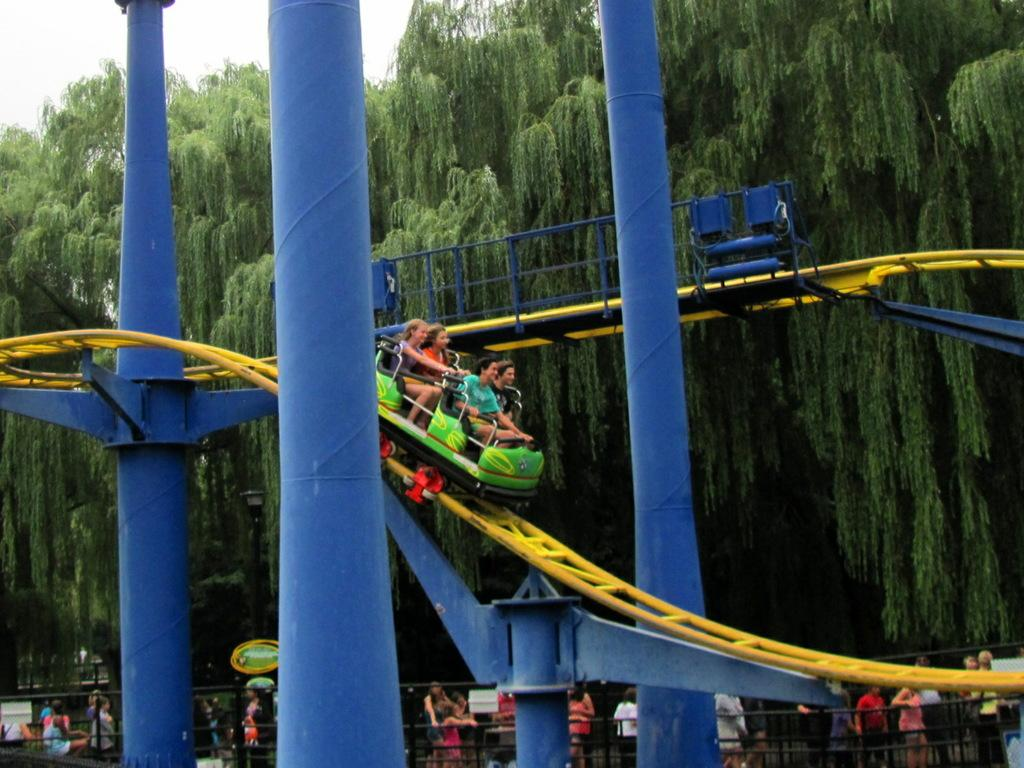What type of activity is taking place in the image? The image contains rides, which suggests it is a recreational or amusement park setting. Can you describe the people at the bottom of the image? There are people at the bottom of the image, which indicates that they might be waiting in line or observing the rides. What can be seen at the top of the image? There are trees at the top of the image, which suggests that the location might be outdoors or in a park-like setting. What are the people in the image doing with the rides? There are people in the image who are doing rides, which means they are actively participating in the recreational activities. What type of arm is visible in the image? There is no arm visible in the image; the focus is on the rides and the people participating in them. 